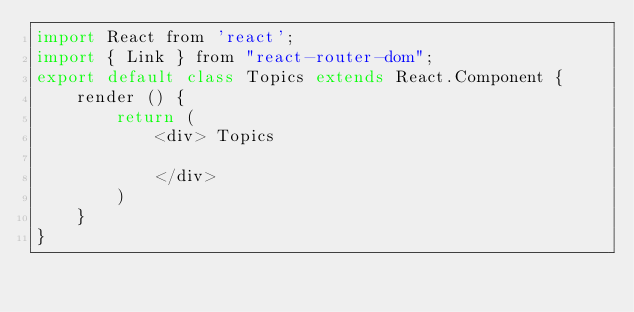Convert code to text. <code><loc_0><loc_0><loc_500><loc_500><_JavaScript_>import React from 'react';
import { Link } from "react-router-dom";
export default class Topics extends React.Component {
    render () {
        return (
            <div> Topics
                 
            </div>
        )
    }
}</code> 